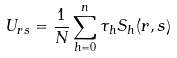Convert formula to latex. <formula><loc_0><loc_0><loc_500><loc_500>U _ { r s } = \frac { 1 } { N } \sum _ { h = 0 } ^ { n } \tau _ { h } S _ { h } ( r , s )</formula> 